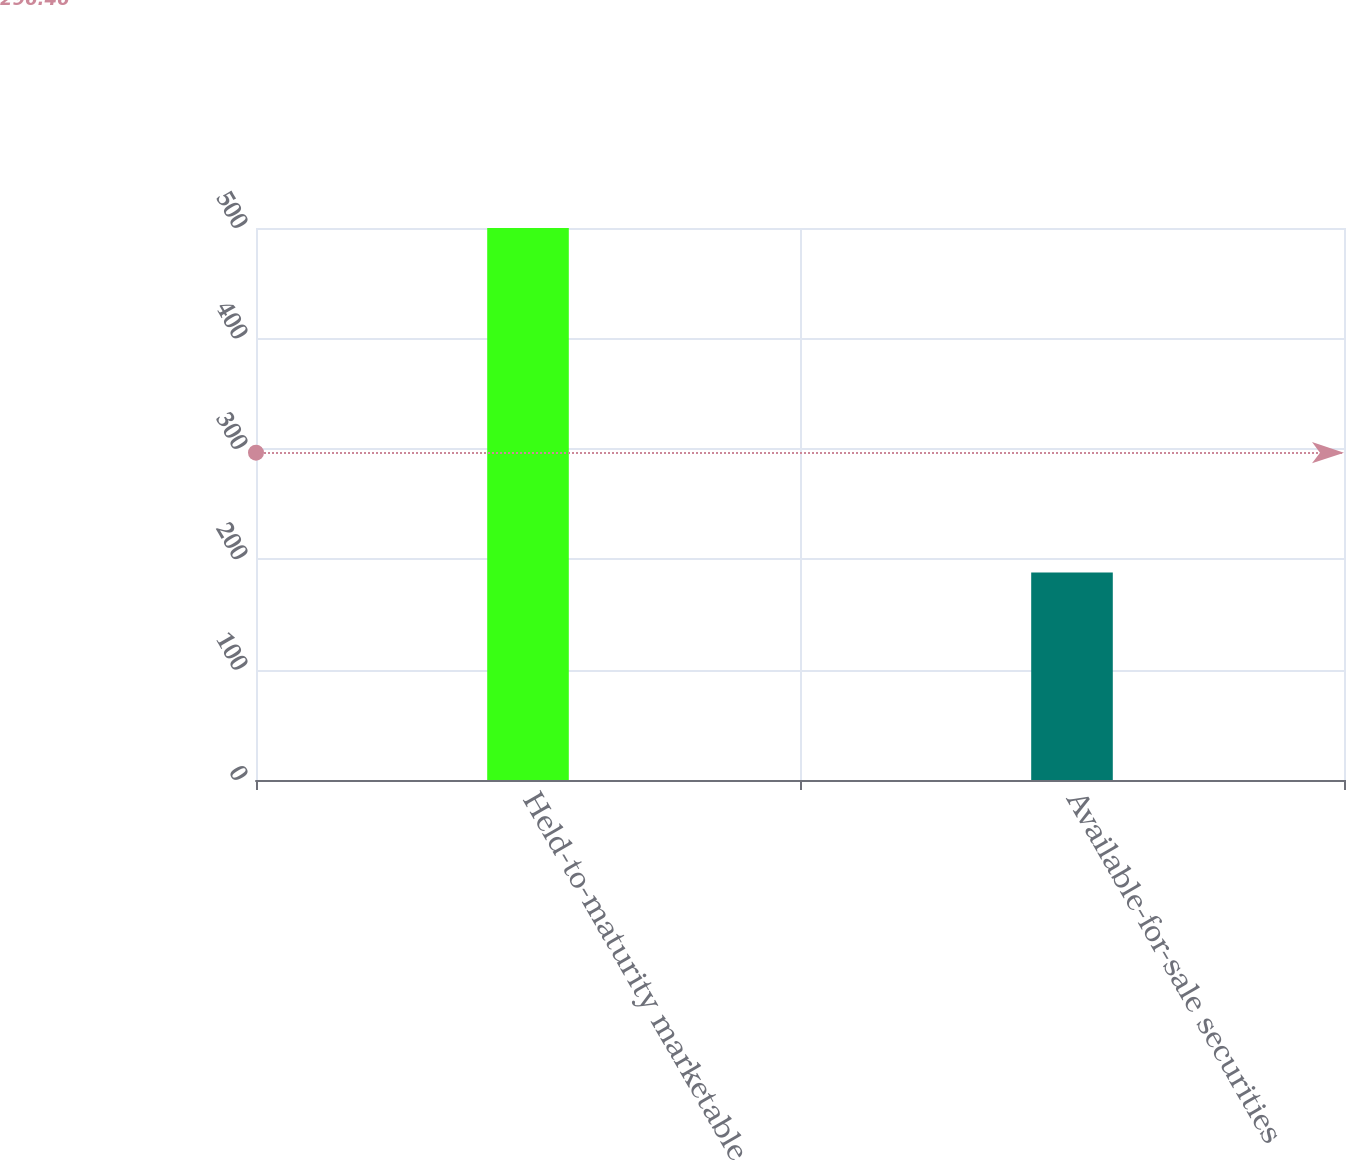Convert chart. <chart><loc_0><loc_0><loc_500><loc_500><bar_chart><fcel>Held-to-maturity marketable<fcel>Available-for-sale securities<nl><fcel>500<fcel>188<nl></chart> 